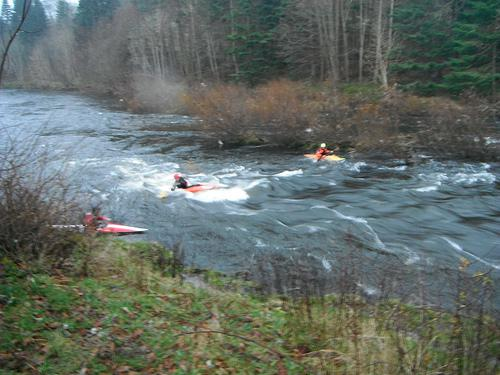Question: why are the people in kayaks?
Choices:
A. To go rowing.
B. They are exercising.
C. To go in the river.
D. They are fishing.
Answer with the letter. Answer: C Question: what are the people in?
Choices:
A. Cars.
B. Kayaks.
C. Trucks.
D. Vans.
Answer with the letter. Answer: B Question: who is in the kayaks?
Choices:
A. Dog.
B. Children.
C. People.
D. The guide.
Answer with the letter. Answer: C Question: how many people are there?
Choices:
A. 1.
B. 2.
C. 3.
D. 6.
Answer with the letter. Answer: C Question: what color is the kayak on the left?
Choices:
A. Blue.
B. Gray.
C. Black.
D. Red.
Answer with the letter. Answer: D 